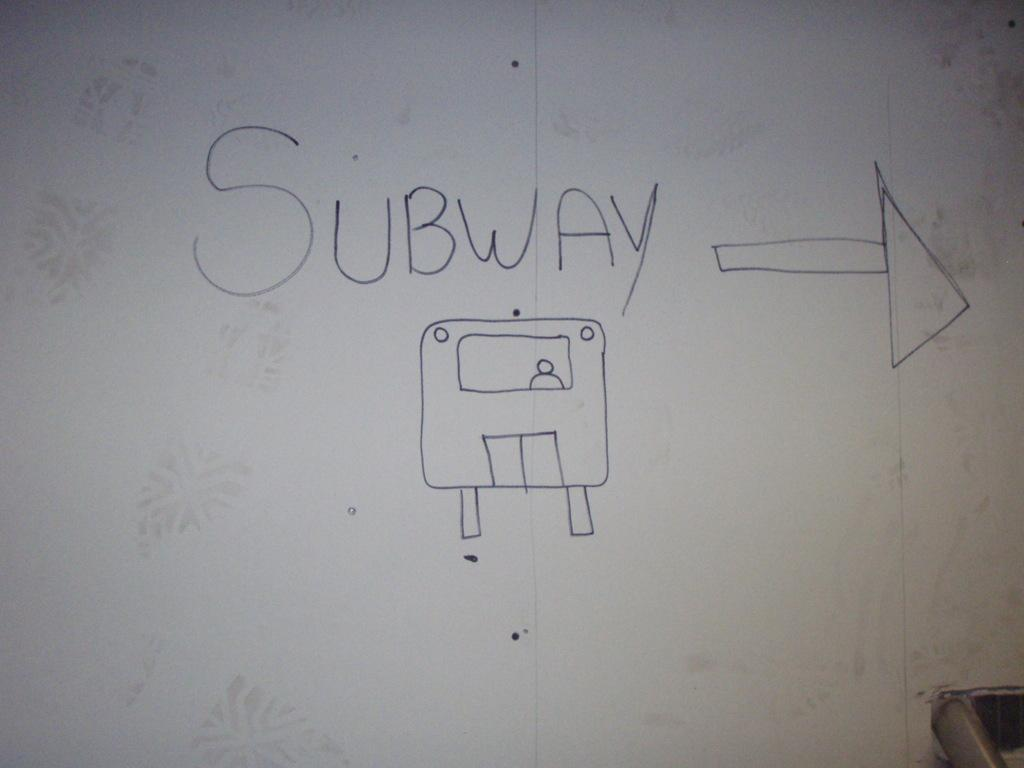<image>
Create a compact narrative representing the image presented. A drawing of the subway with an arrow pointing to the right 